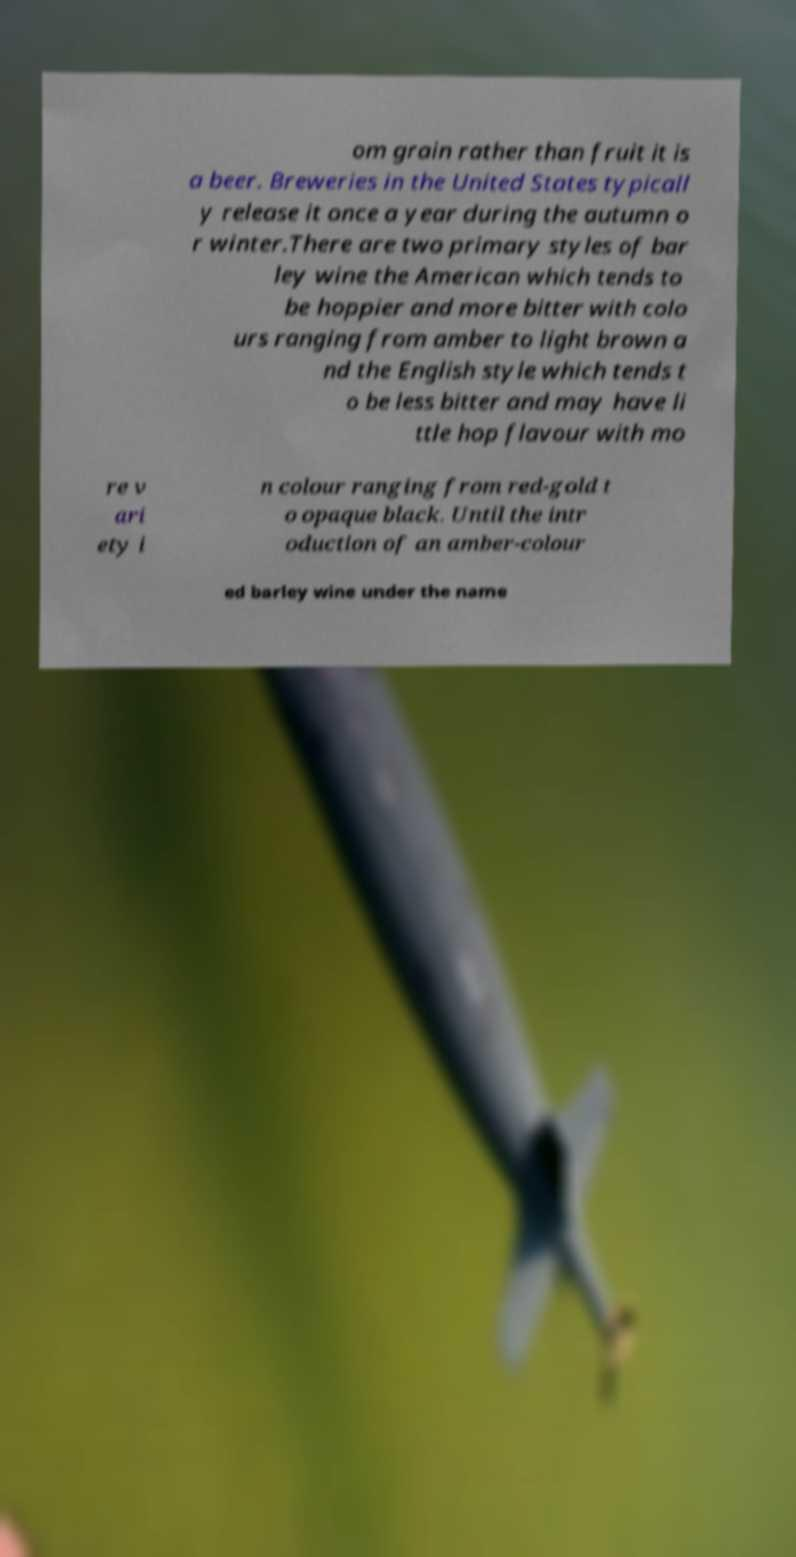Can you accurately transcribe the text from the provided image for me? om grain rather than fruit it is a beer. Breweries in the United States typicall y release it once a year during the autumn o r winter.There are two primary styles of bar ley wine the American which tends to be hoppier and more bitter with colo urs ranging from amber to light brown a nd the English style which tends t o be less bitter and may have li ttle hop flavour with mo re v ari ety i n colour ranging from red-gold t o opaque black. Until the intr oduction of an amber-colour ed barley wine under the name 